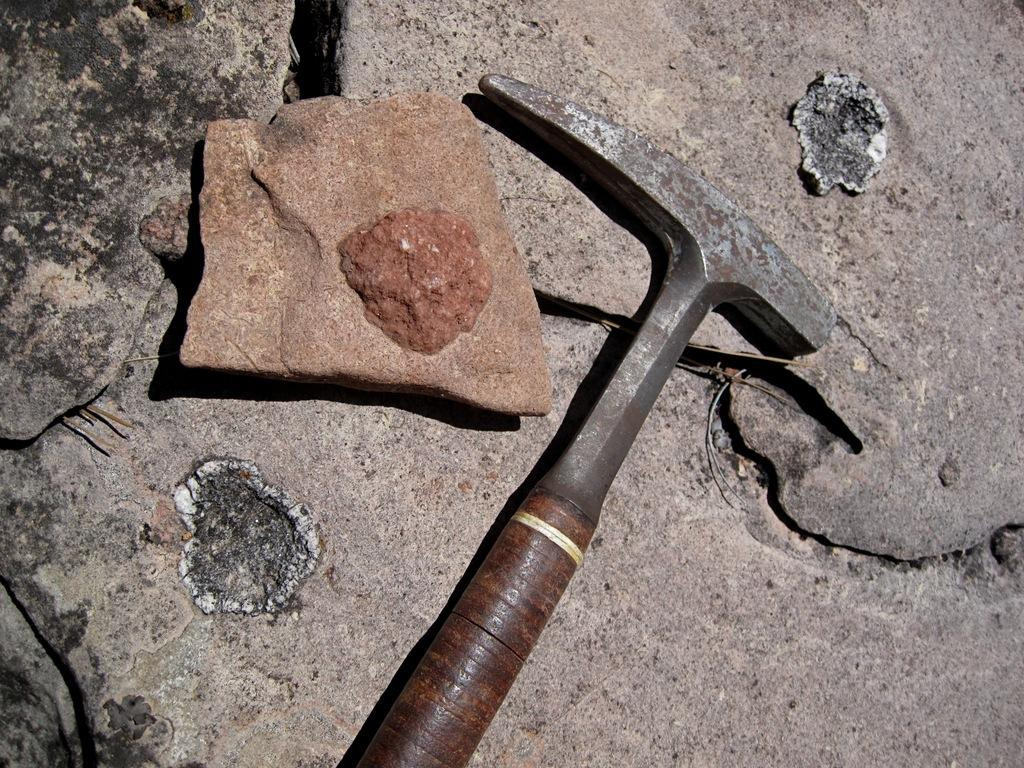What tool is present in the image? There is a hammer in the image. What object is the hammer positioned near? The hammer is near a stone. How many girls are playing the guitar in the image? There are no girls or guitars present in the image; it only features a hammer and a stone. 